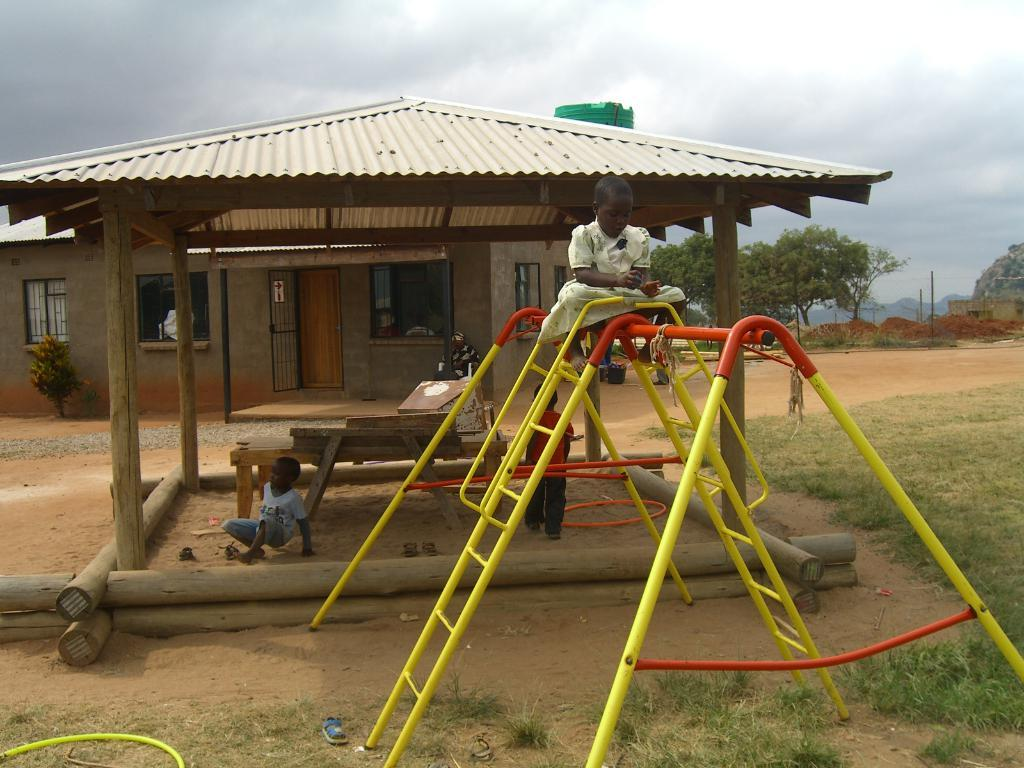What is the girl doing in the image? The girl is sitting on an iron rod. What can be seen in the background of the image? There is a house, a window, and a door in the background. What is the boy doing in the image? The boy is playing in the sand. What type of jelly is the girl using to sit on the iron rod? There is no jelly present in the image; the girl is sitting on an iron rod. What kind of test is the boy taking while playing in the sand? There is no test present in the image; the boy is simply playing in the sand. 